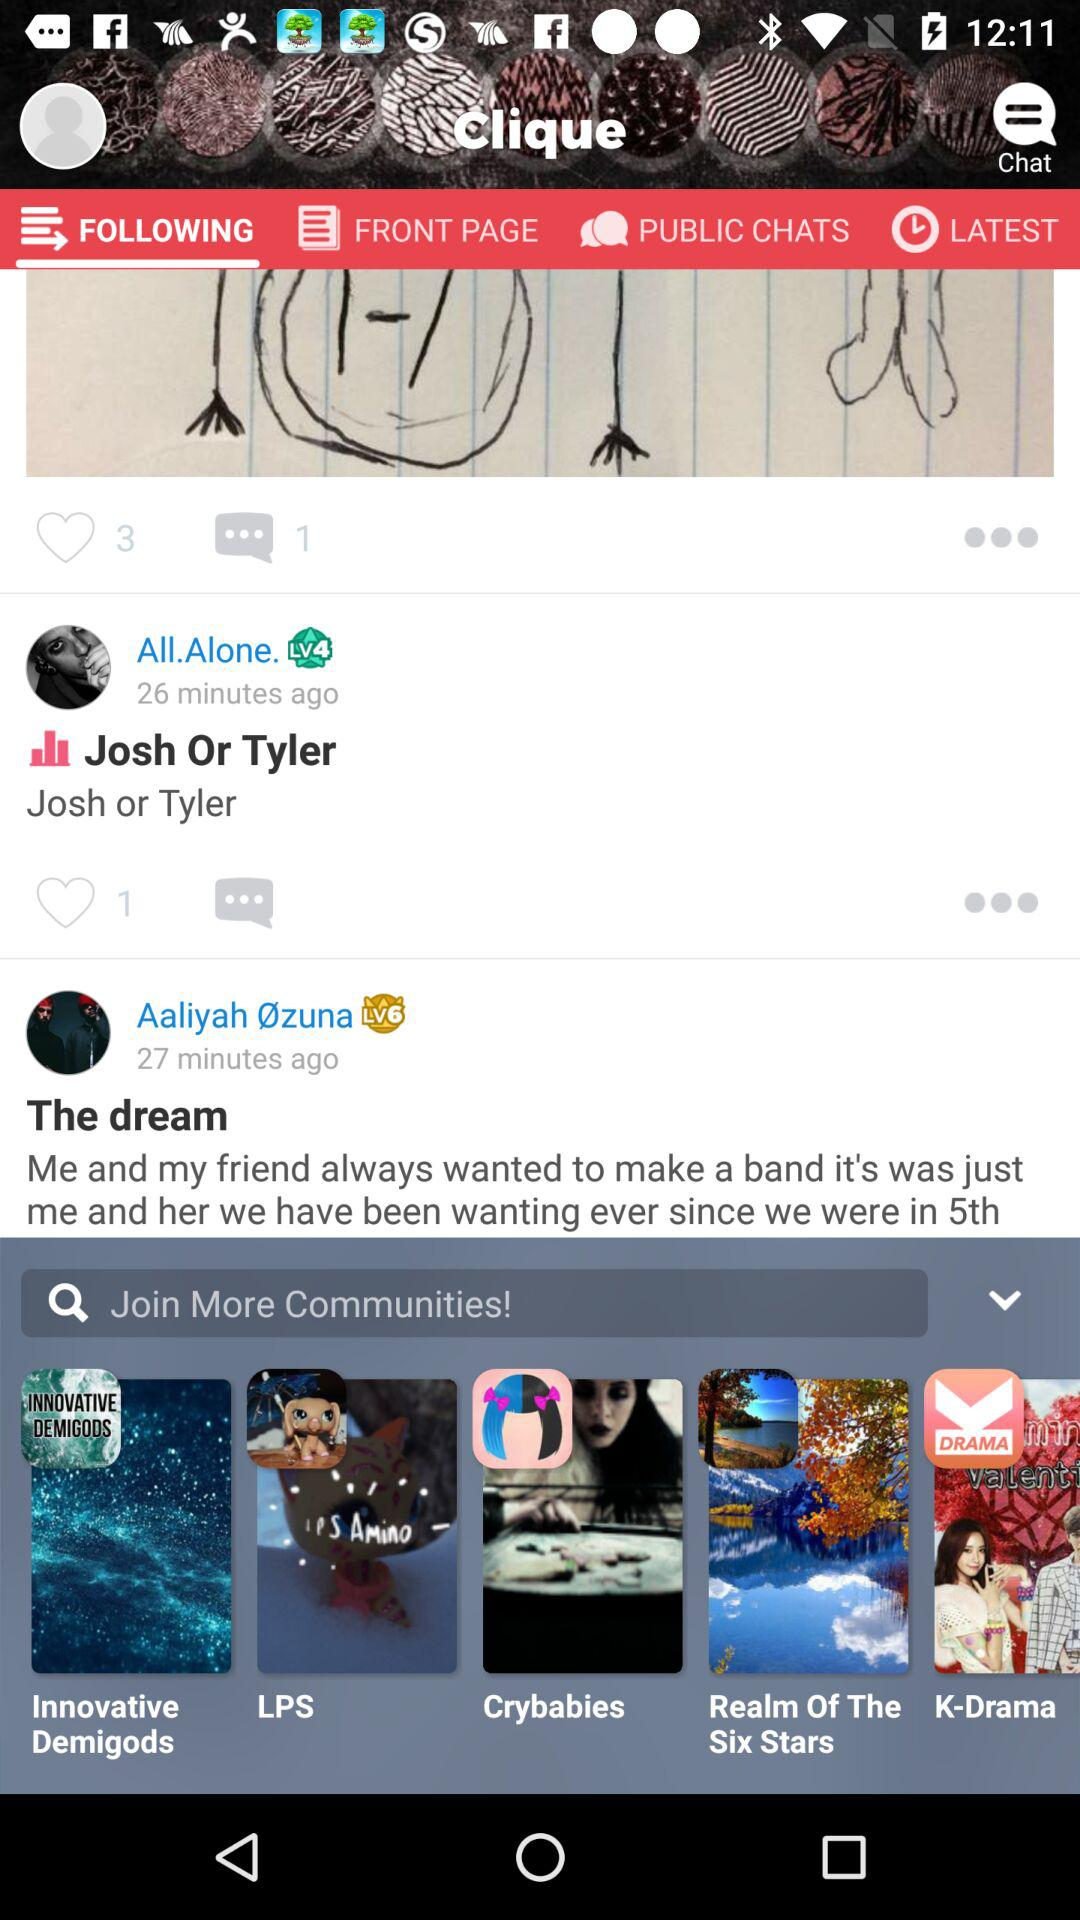Which tab am I on? You are on the "FOLLOWING" tab. 